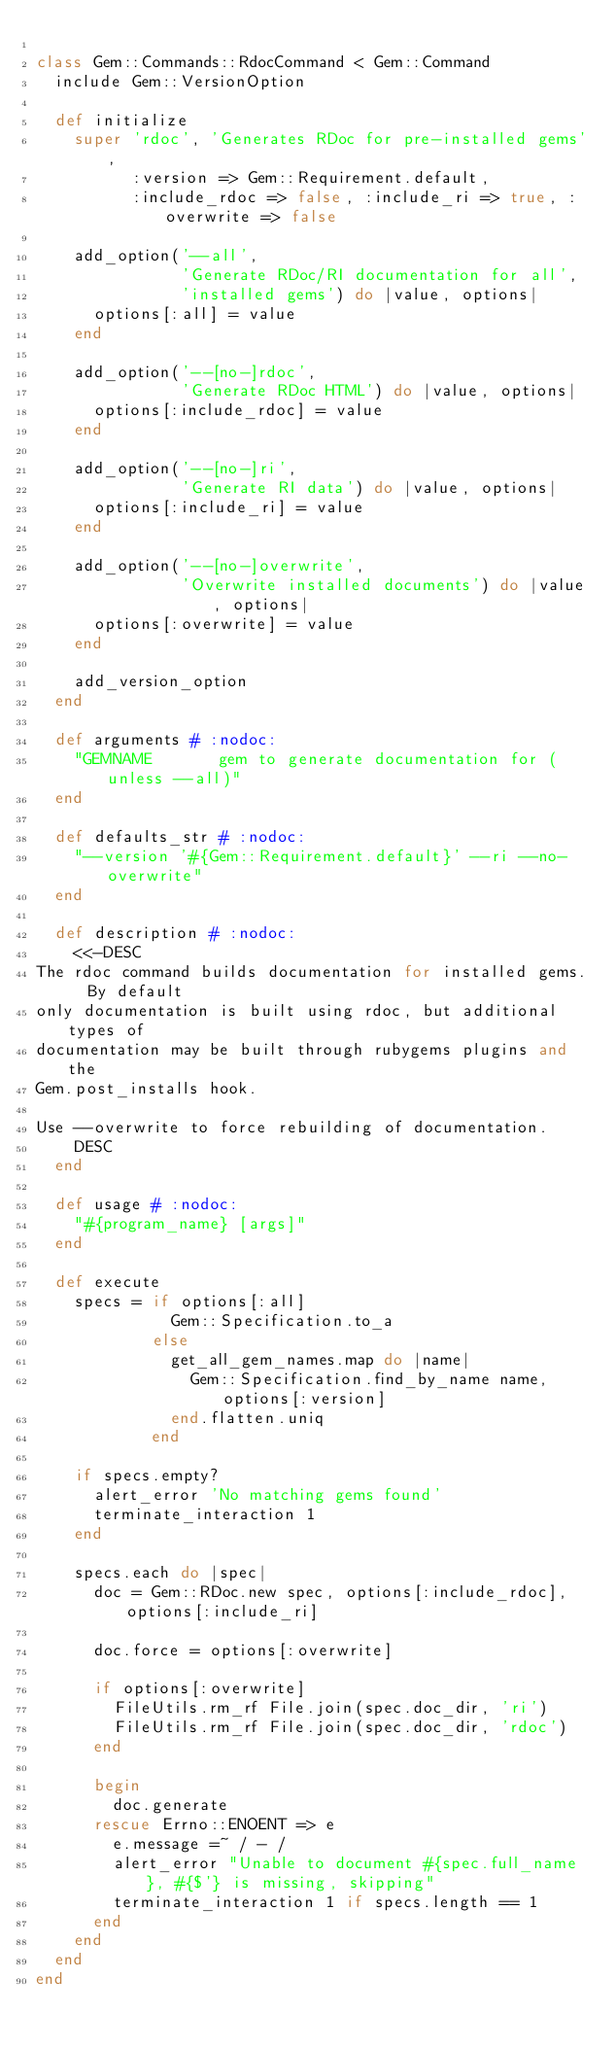Convert code to text. <code><loc_0><loc_0><loc_500><loc_500><_Ruby_>
class Gem::Commands::RdocCommand < Gem::Command
  include Gem::VersionOption

  def initialize
    super 'rdoc', 'Generates RDoc for pre-installed gems',
          :version => Gem::Requirement.default,
          :include_rdoc => false, :include_ri => true, :overwrite => false

    add_option('--all',
               'Generate RDoc/RI documentation for all',
               'installed gems') do |value, options|
      options[:all] = value
    end

    add_option('--[no-]rdoc',
               'Generate RDoc HTML') do |value, options|
      options[:include_rdoc] = value
    end

    add_option('--[no-]ri',
               'Generate RI data') do |value, options|
      options[:include_ri] = value
    end

    add_option('--[no-]overwrite',
               'Overwrite installed documents') do |value, options|
      options[:overwrite] = value
    end

    add_version_option
  end

  def arguments # :nodoc:
    "GEMNAME       gem to generate documentation for (unless --all)"
  end

  def defaults_str # :nodoc:
    "--version '#{Gem::Requirement.default}' --ri --no-overwrite"
  end

  def description # :nodoc:
    <<-DESC
The rdoc command builds documentation for installed gems.  By default
only documentation is built using rdoc, but additional types of
documentation may be built through rubygems plugins and the
Gem.post_installs hook.

Use --overwrite to force rebuilding of documentation.
    DESC
  end

  def usage # :nodoc:
    "#{program_name} [args]"
  end

  def execute
    specs = if options[:all]
              Gem::Specification.to_a
            else
              get_all_gem_names.map do |name|
                Gem::Specification.find_by_name name, options[:version]
              end.flatten.uniq
            end

    if specs.empty?
      alert_error 'No matching gems found'
      terminate_interaction 1
    end

    specs.each do |spec|
      doc = Gem::RDoc.new spec, options[:include_rdoc], options[:include_ri]

      doc.force = options[:overwrite]

      if options[:overwrite]
        FileUtils.rm_rf File.join(spec.doc_dir, 'ri')
        FileUtils.rm_rf File.join(spec.doc_dir, 'rdoc')
      end

      begin
        doc.generate
      rescue Errno::ENOENT => e
        e.message =~ / - /
        alert_error "Unable to document #{spec.full_name}, #{$'} is missing, skipping"
        terminate_interaction 1 if specs.length == 1
      end
    end
  end
end
</code> 